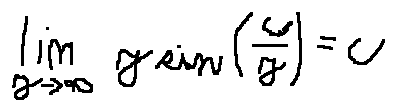<formula> <loc_0><loc_0><loc_500><loc_500>\lim \lim i t s _ { y \rightarrow \infty } y \sin ( \frac { c } { y } ) = c</formula> 